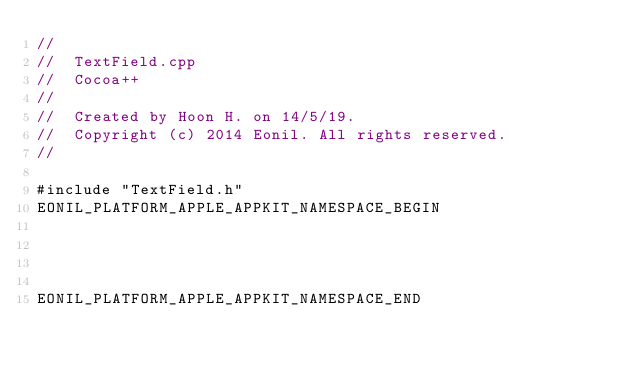Convert code to text. <code><loc_0><loc_0><loc_500><loc_500><_ObjectiveC_>//
//  TextField.cpp
//  Cocoa++
//
//  Created by Hoon H. on 14/5/19.
//  Copyright (c) 2014 Eonil. All rights reserved.
//

#include "TextField.h"
EONIL_PLATFORM_APPLE_APPKIT_NAMESPACE_BEGIN




EONIL_PLATFORM_APPLE_APPKIT_NAMESPACE_END
</code> 